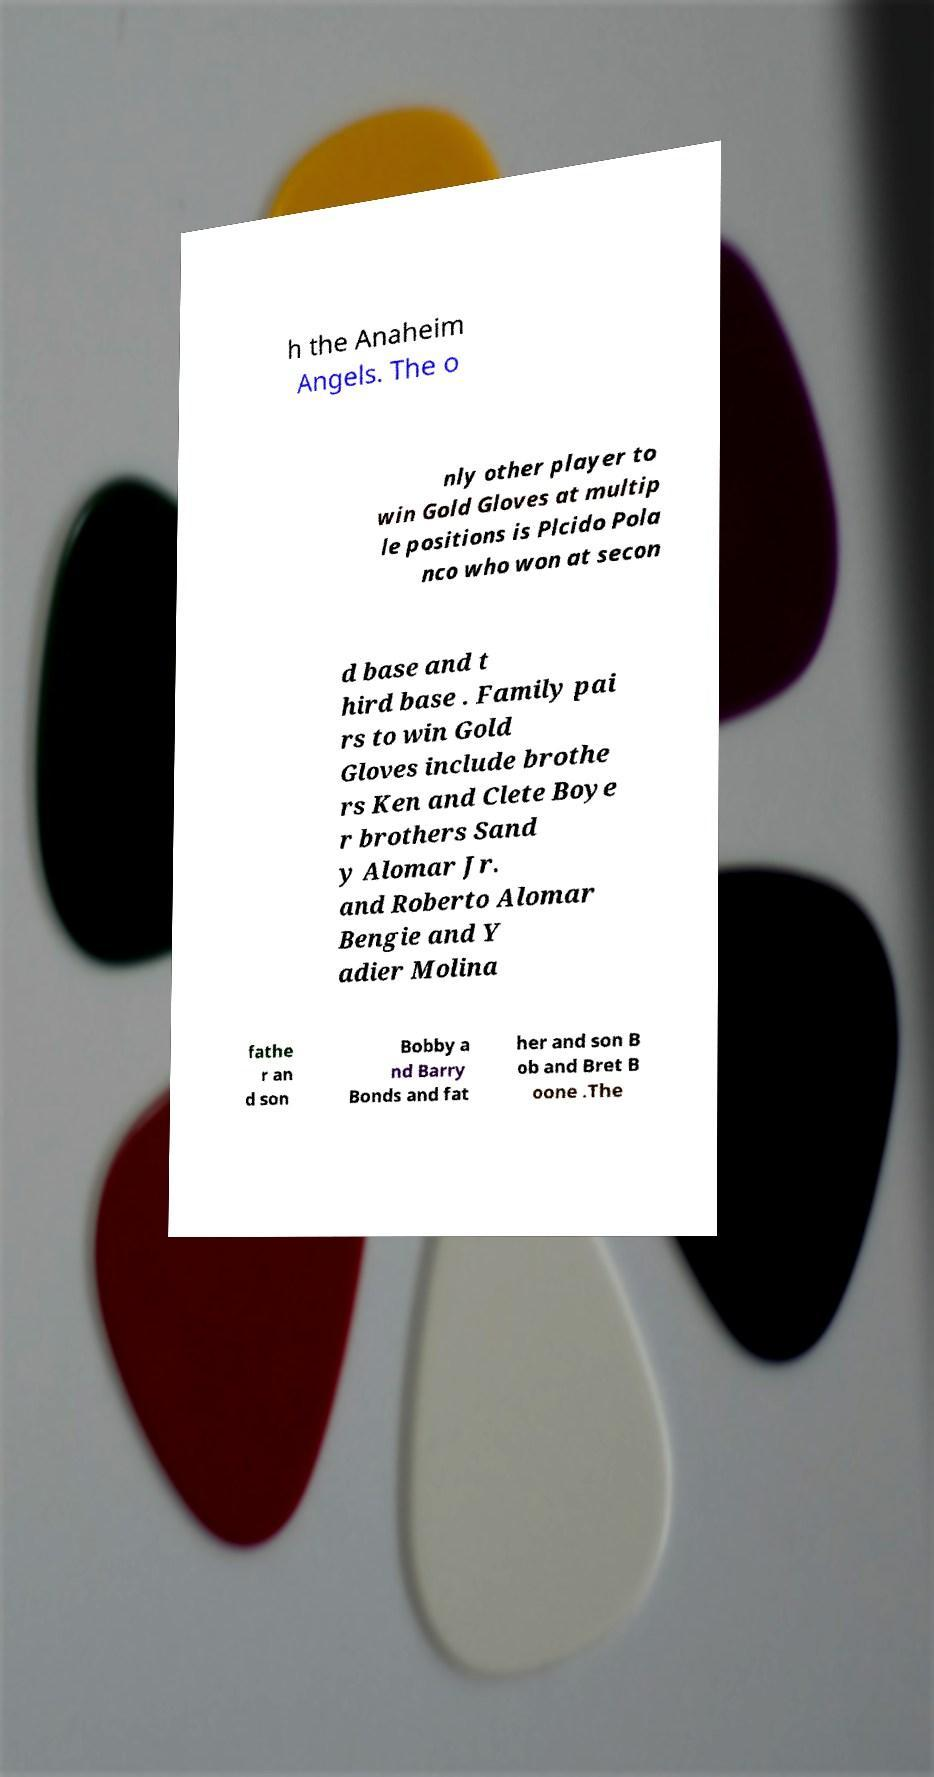For documentation purposes, I need the text within this image transcribed. Could you provide that? h the Anaheim Angels. The o nly other player to win Gold Gloves at multip le positions is Plcido Pola nco who won at secon d base and t hird base . Family pai rs to win Gold Gloves include brothe rs Ken and Clete Boye r brothers Sand y Alomar Jr. and Roberto Alomar Bengie and Y adier Molina fathe r an d son Bobby a nd Barry Bonds and fat her and son B ob and Bret B oone .The 